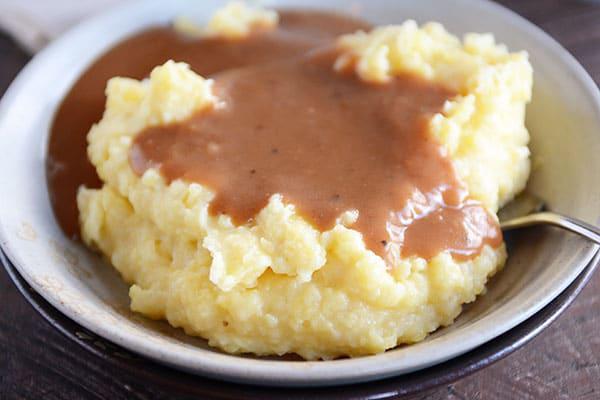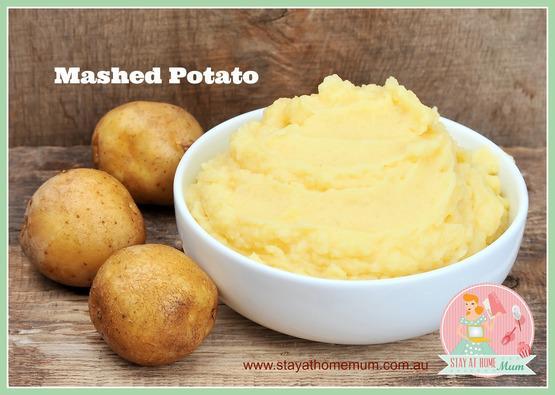The first image is the image on the left, the second image is the image on the right. Analyze the images presented: Is the assertion "An image includes ungarnished mashed potatoes in a round white bowl with a fork near it and a container of something behind it." valid? Answer yes or no. No. 